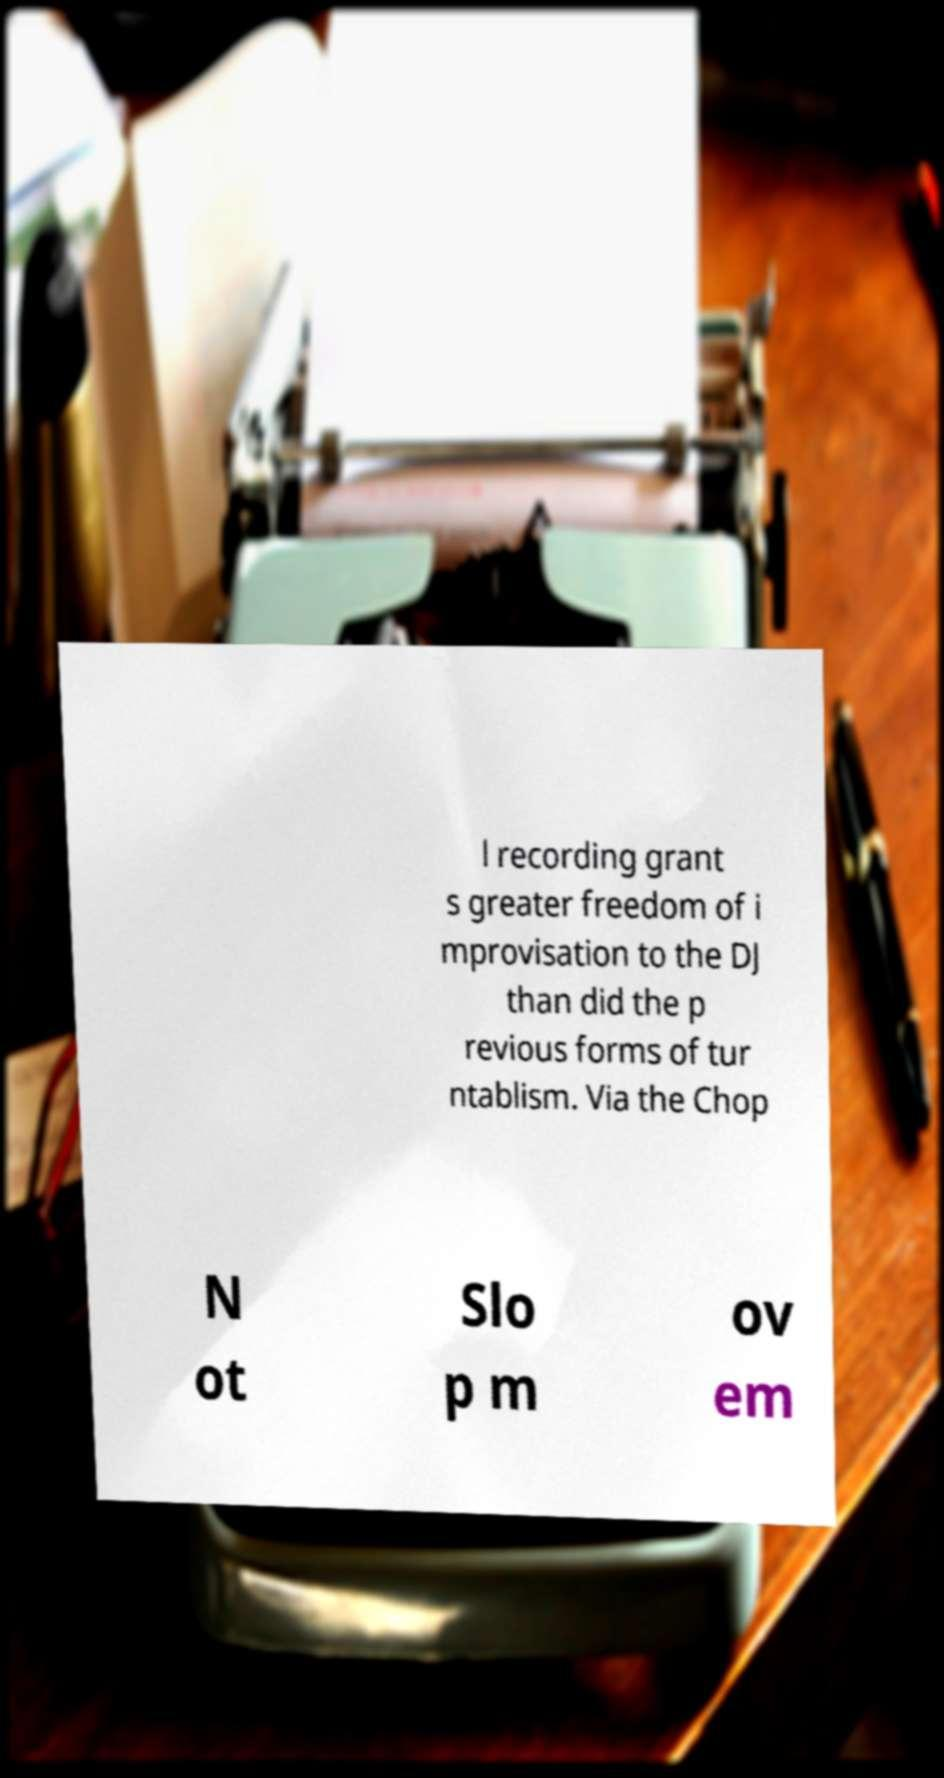What messages or text are displayed in this image? I need them in a readable, typed format. l recording grant s greater freedom of i mprovisation to the DJ than did the p revious forms of tur ntablism. Via the Chop N ot Slo p m ov em 